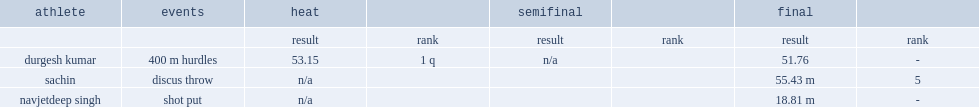What is the final result for navjetdeep singh of india in the shot put event at the 2011 commonwealth youth games? 18.81 m. 